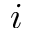<formula> <loc_0><loc_0><loc_500><loc_500>i</formula> 